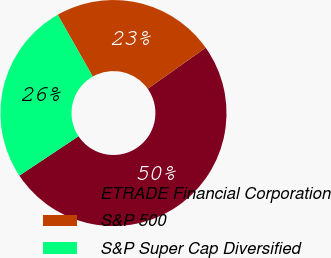<chart> <loc_0><loc_0><loc_500><loc_500><pie_chart><fcel>ETRADE Financial Corporation<fcel>S&P 500<fcel>S&P Super Cap Diversified<nl><fcel>50.47%<fcel>23.41%<fcel>26.12%<nl></chart> 